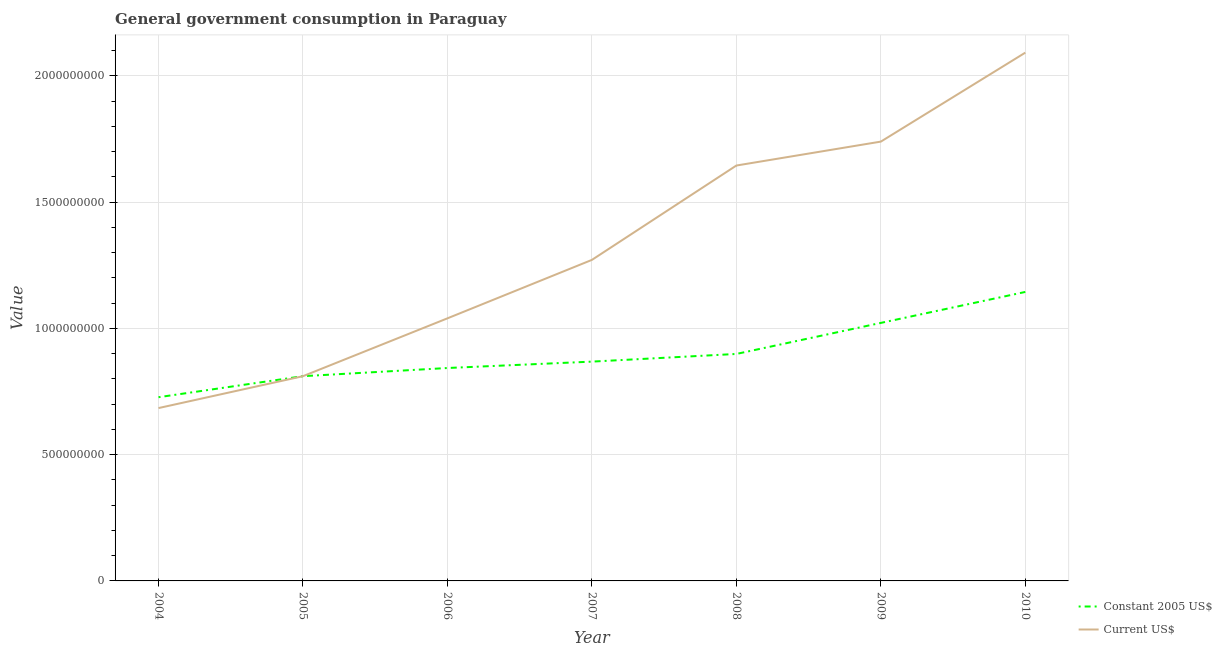How many different coloured lines are there?
Your response must be concise. 2. Does the line corresponding to value consumed in constant 2005 us$ intersect with the line corresponding to value consumed in current us$?
Offer a very short reply. Yes. Is the number of lines equal to the number of legend labels?
Offer a terse response. Yes. What is the value consumed in constant 2005 us$ in 2009?
Provide a short and direct response. 1.02e+09. Across all years, what is the maximum value consumed in current us$?
Offer a terse response. 2.09e+09. Across all years, what is the minimum value consumed in current us$?
Give a very brief answer. 6.85e+08. In which year was the value consumed in constant 2005 us$ maximum?
Your response must be concise. 2010. What is the total value consumed in constant 2005 us$ in the graph?
Provide a short and direct response. 6.32e+09. What is the difference between the value consumed in current us$ in 2009 and that in 2010?
Ensure brevity in your answer.  -3.52e+08. What is the difference between the value consumed in current us$ in 2007 and the value consumed in constant 2005 us$ in 2006?
Offer a terse response. 4.28e+08. What is the average value consumed in current us$ per year?
Your answer should be very brief. 1.33e+09. In the year 2005, what is the difference between the value consumed in current us$ and value consumed in constant 2005 us$?
Offer a terse response. 0. In how many years, is the value consumed in current us$ greater than 1300000000?
Provide a succinct answer. 3. What is the ratio of the value consumed in constant 2005 us$ in 2005 to that in 2006?
Offer a terse response. 0.96. What is the difference between the highest and the second highest value consumed in constant 2005 us$?
Provide a succinct answer. 1.23e+08. What is the difference between the highest and the lowest value consumed in constant 2005 us$?
Keep it short and to the point. 4.17e+08. In how many years, is the value consumed in current us$ greater than the average value consumed in current us$ taken over all years?
Your answer should be very brief. 3. Is the sum of the value consumed in constant 2005 us$ in 2008 and 2010 greater than the maximum value consumed in current us$ across all years?
Ensure brevity in your answer.  No. Does the value consumed in constant 2005 us$ monotonically increase over the years?
Give a very brief answer. Yes. Is the value consumed in constant 2005 us$ strictly less than the value consumed in current us$ over the years?
Make the answer very short. No. Are the values on the major ticks of Y-axis written in scientific E-notation?
Your answer should be compact. No. Does the graph contain any zero values?
Your answer should be very brief. No. Does the graph contain grids?
Keep it short and to the point. Yes. Where does the legend appear in the graph?
Your answer should be compact. Bottom right. How are the legend labels stacked?
Provide a succinct answer. Vertical. What is the title of the graph?
Your answer should be compact. General government consumption in Paraguay. What is the label or title of the X-axis?
Ensure brevity in your answer.  Year. What is the label or title of the Y-axis?
Provide a succinct answer. Value. What is the Value in Constant 2005 US$ in 2004?
Ensure brevity in your answer.  7.28e+08. What is the Value in Current US$ in 2004?
Your answer should be very brief. 6.85e+08. What is the Value in Constant 2005 US$ in 2005?
Keep it short and to the point. 8.11e+08. What is the Value in Current US$ in 2005?
Offer a terse response. 8.11e+08. What is the Value of Constant 2005 US$ in 2006?
Give a very brief answer. 8.43e+08. What is the Value in Current US$ in 2006?
Give a very brief answer. 1.04e+09. What is the Value in Constant 2005 US$ in 2007?
Provide a succinct answer. 8.69e+08. What is the Value in Current US$ in 2007?
Offer a very short reply. 1.27e+09. What is the Value in Constant 2005 US$ in 2008?
Your response must be concise. 8.99e+08. What is the Value of Current US$ in 2008?
Your response must be concise. 1.65e+09. What is the Value in Constant 2005 US$ in 2009?
Provide a short and direct response. 1.02e+09. What is the Value of Current US$ in 2009?
Ensure brevity in your answer.  1.74e+09. What is the Value of Constant 2005 US$ in 2010?
Keep it short and to the point. 1.14e+09. What is the Value of Current US$ in 2010?
Keep it short and to the point. 2.09e+09. Across all years, what is the maximum Value in Constant 2005 US$?
Your answer should be compact. 1.14e+09. Across all years, what is the maximum Value of Current US$?
Keep it short and to the point. 2.09e+09. Across all years, what is the minimum Value in Constant 2005 US$?
Make the answer very short. 7.28e+08. Across all years, what is the minimum Value in Current US$?
Offer a very short reply. 6.85e+08. What is the total Value of Constant 2005 US$ in the graph?
Provide a succinct answer. 6.32e+09. What is the total Value in Current US$ in the graph?
Ensure brevity in your answer.  9.28e+09. What is the difference between the Value of Constant 2005 US$ in 2004 and that in 2005?
Make the answer very short. -8.33e+07. What is the difference between the Value of Current US$ in 2004 and that in 2005?
Your answer should be very brief. -1.26e+08. What is the difference between the Value of Constant 2005 US$ in 2004 and that in 2006?
Your answer should be compact. -1.16e+08. What is the difference between the Value of Current US$ in 2004 and that in 2006?
Ensure brevity in your answer.  -3.55e+08. What is the difference between the Value in Constant 2005 US$ in 2004 and that in 2007?
Ensure brevity in your answer.  -1.41e+08. What is the difference between the Value of Current US$ in 2004 and that in 2007?
Offer a very short reply. -5.87e+08. What is the difference between the Value of Constant 2005 US$ in 2004 and that in 2008?
Offer a very short reply. -1.71e+08. What is the difference between the Value in Current US$ in 2004 and that in 2008?
Keep it short and to the point. -9.61e+08. What is the difference between the Value in Constant 2005 US$ in 2004 and that in 2009?
Your response must be concise. -2.94e+08. What is the difference between the Value of Current US$ in 2004 and that in 2009?
Provide a succinct answer. -1.06e+09. What is the difference between the Value of Constant 2005 US$ in 2004 and that in 2010?
Keep it short and to the point. -4.17e+08. What is the difference between the Value in Current US$ in 2004 and that in 2010?
Ensure brevity in your answer.  -1.41e+09. What is the difference between the Value in Constant 2005 US$ in 2005 and that in 2006?
Your answer should be compact. -3.24e+07. What is the difference between the Value of Current US$ in 2005 and that in 2006?
Provide a short and direct response. -2.29e+08. What is the difference between the Value in Constant 2005 US$ in 2005 and that in 2007?
Make the answer very short. -5.77e+07. What is the difference between the Value in Current US$ in 2005 and that in 2007?
Ensure brevity in your answer.  -4.61e+08. What is the difference between the Value of Constant 2005 US$ in 2005 and that in 2008?
Keep it short and to the point. -8.81e+07. What is the difference between the Value in Current US$ in 2005 and that in 2008?
Give a very brief answer. -8.34e+08. What is the difference between the Value of Constant 2005 US$ in 2005 and that in 2009?
Provide a succinct answer. -2.11e+08. What is the difference between the Value of Current US$ in 2005 and that in 2009?
Your response must be concise. -9.29e+08. What is the difference between the Value of Constant 2005 US$ in 2005 and that in 2010?
Make the answer very short. -3.34e+08. What is the difference between the Value of Current US$ in 2005 and that in 2010?
Offer a very short reply. -1.28e+09. What is the difference between the Value of Constant 2005 US$ in 2006 and that in 2007?
Your answer should be compact. -2.53e+07. What is the difference between the Value of Current US$ in 2006 and that in 2007?
Your answer should be very brief. -2.31e+08. What is the difference between the Value of Constant 2005 US$ in 2006 and that in 2008?
Your answer should be very brief. -5.57e+07. What is the difference between the Value in Current US$ in 2006 and that in 2008?
Offer a very short reply. -6.05e+08. What is the difference between the Value of Constant 2005 US$ in 2006 and that in 2009?
Your answer should be very brief. -1.79e+08. What is the difference between the Value in Current US$ in 2006 and that in 2009?
Offer a very short reply. -7.00e+08. What is the difference between the Value of Constant 2005 US$ in 2006 and that in 2010?
Ensure brevity in your answer.  -3.01e+08. What is the difference between the Value of Current US$ in 2006 and that in 2010?
Provide a succinct answer. -1.05e+09. What is the difference between the Value of Constant 2005 US$ in 2007 and that in 2008?
Provide a succinct answer. -3.04e+07. What is the difference between the Value of Current US$ in 2007 and that in 2008?
Your response must be concise. -3.74e+08. What is the difference between the Value of Constant 2005 US$ in 2007 and that in 2009?
Your response must be concise. -1.53e+08. What is the difference between the Value of Current US$ in 2007 and that in 2009?
Provide a succinct answer. -4.68e+08. What is the difference between the Value of Constant 2005 US$ in 2007 and that in 2010?
Make the answer very short. -2.76e+08. What is the difference between the Value in Current US$ in 2007 and that in 2010?
Your answer should be compact. -8.21e+08. What is the difference between the Value in Constant 2005 US$ in 2008 and that in 2009?
Your answer should be compact. -1.23e+08. What is the difference between the Value in Current US$ in 2008 and that in 2009?
Your answer should be very brief. -9.47e+07. What is the difference between the Value in Constant 2005 US$ in 2008 and that in 2010?
Offer a terse response. -2.46e+08. What is the difference between the Value of Current US$ in 2008 and that in 2010?
Make the answer very short. -4.47e+08. What is the difference between the Value in Constant 2005 US$ in 2009 and that in 2010?
Your response must be concise. -1.23e+08. What is the difference between the Value in Current US$ in 2009 and that in 2010?
Ensure brevity in your answer.  -3.52e+08. What is the difference between the Value of Constant 2005 US$ in 2004 and the Value of Current US$ in 2005?
Your answer should be very brief. -8.33e+07. What is the difference between the Value of Constant 2005 US$ in 2004 and the Value of Current US$ in 2006?
Provide a succinct answer. -3.12e+08. What is the difference between the Value of Constant 2005 US$ in 2004 and the Value of Current US$ in 2007?
Your answer should be very brief. -5.44e+08. What is the difference between the Value in Constant 2005 US$ in 2004 and the Value in Current US$ in 2008?
Your answer should be very brief. -9.18e+08. What is the difference between the Value in Constant 2005 US$ in 2004 and the Value in Current US$ in 2009?
Ensure brevity in your answer.  -1.01e+09. What is the difference between the Value of Constant 2005 US$ in 2004 and the Value of Current US$ in 2010?
Your answer should be very brief. -1.36e+09. What is the difference between the Value of Constant 2005 US$ in 2005 and the Value of Current US$ in 2006?
Your answer should be very brief. -2.29e+08. What is the difference between the Value of Constant 2005 US$ in 2005 and the Value of Current US$ in 2007?
Offer a terse response. -4.61e+08. What is the difference between the Value of Constant 2005 US$ in 2005 and the Value of Current US$ in 2008?
Make the answer very short. -8.34e+08. What is the difference between the Value of Constant 2005 US$ in 2005 and the Value of Current US$ in 2009?
Offer a terse response. -9.29e+08. What is the difference between the Value in Constant 2005 US$ in 2005 and the Value in Current US$ in 2010?
Provide a short and direct response. -1.28e+09. What is the difference between the Value of Constant 2005 US$ in 2006 and the Value of Current US$ in 2007?
Provide a succinct answer. -4.28e+08. What is the difference between the Value of Constant 2005 US$ in 2006 and the Value of Current US$ in 2008?
Ensure brevity in your answer.  -8.02e+08. What is the difference between the Value in Constant 2005 US$ in 2006 and the Value in Current US$ in 2009?
Ensure brevity in your answer.  -8.97e+08. What is the difference between the Value in Constant 2005 US$ in 2006 and the Value in Current US$ in 2010?
Your answer should be compact. -1.25e+09. What is the difference between the Value in Constant 2005 US$ in 2007 and the Value in Current US$ in 2008?
Give a very brief answer. -7.77e+08. What is the difference between the Value in Constant 2005 US$ in 2007 and the Value in Current US$ in 2009?
Provide a succinct answer. -8.71e+08. What is the difference between the Value of Constant 2005 US$ in 2007 and the Value of Current US$ in 2010?
Provide a succinct answer. -1.22e+09. What is the difference between the Value of Constant 2005 US$ in 2008 and the Value of Current US$ in 2009?
Your response must be concise. -8.41e+08. What is the difference between the Value of Constant 2005 US$ in 2008 and the Value of Current US$ in 2010?
Offer a terse response. -1.19e+09. What is the difference between the Value of Constant 2005 US$ in 2009 and the Value of Current US$ in 2010?
Ensure brevity in your answer.  -1.07e+09. What is the average Value in Constant 2005 US$ per year?
Offer a very short reply. 9.02e+08. What is the average Value of Current US$ per year?
Ensure brevity in your answer.  1.33e+09. In the year 2004, what is the difference between the Value of Constant 2005 US$ and Value of Current US$?
Your response must be concise. 4.30e+07. In the year 2005, what is the difference between the Value in Constant 2005 US$ and Value in Current US$?
Ensure brevity in your answer.  0. In the year 2006, what is the difference between the Value in Constant 2005 US$ and Value in Current US$?
Provide a short and direct response. -1.97e+08. In the year 2007, what is the difference between the Value in Constant 2005 US$ and Value in Current US$?
Ensure brevity in your answer.  -4.03e+08. In the year 2008, what is the difference between the Value of Constant 2005 US$ and Value of Current US$?
Give a very brief answer. -7.46e+08. In the year 2009, what is the difference between the Value of Constant 2005 US$ and Value of Current US$?
Your response must be concise. -7.18e+08. In the year 2010, what is the difference between the Value in Constant 2005 US$ and Value in Current US$?
Offer a very short reply. -9.48e+08. What is the ratio of the Value in Constant 2005 US$ in 2004 to that in 2005?
Your answer should be very brief. 0.9. What is the ratio of the Value in Current US$ in 2004 to that in 2005?
Give a very brief answer. 0.84. What is the ratio of the Value of Constant 2005 US$ in 2004 to that in 2006?
Your response must be concise. 0.86. What is the ratio of the Value in Current US$ in 2004 to that in 2006?
Your response must be concise. 0.66. What is the ratio of the Value in Constant 2005 US$ in 2004 to that in 2007?
Ensure brevity in your answer.  0.84. What is the ratio of the Value in Current US$ in 2004 to that in 2007?
Provide a succinct answer. 0.54. What is the ratio of the Value of Constant 2005 US$ in 2004 to that in 2008?
Your response must be concise. 0.81. What is the ratio of the Value of Current US$ in 2004 to that in 2008?
Your answer should be very brief. 0.42. What is the ratio of the Value in Constant 2005 US$ in 2004 to that in 2009?
Your response must be concise. 0.71. What is the ratio of the Value of Current US$ in 2004 to that in 2009?
Keep it short and to the point. 0.39. What is the ratio of the Value of Constant 2005 US$ in 2004 to that in 2010?
Provide a succinct answer. 0.64. What is the ratio of the Value in Current US$ in 2004 to that in 2010?
Offer a very short reply. 0.33. What is the ratio of the Value of Constant 2005 US$ in 2005 to that in 2006?
Provide a succinct answer. 0.96. What is the ratio of the Value of Current US$ in 2005 to that in 2006?
Keep it short and to the point. 0.78. What is the ratio of the Value in Constant 2005 US$ in 2005 to that in 2007?
Your answer should be compact. 0.93. What is the ratio of the Value of Current US$ in 2005 to that in 2007?
Keep it short and to the point. 0.64. What is the ratio of the Value of Constant 2005 US$ in 2005 to that in 2008?
Provide a succinct answer. 0.9. What is the ratio of the Value in Current US$ in 2005 to that in 2008?
Your answer should be compact. 0.49. What is the ratio of the Value of Constant 2005 US$ in 2005 to that in 2009?
Offer a terse response. 0.79. What is the ratio of the Value in Current US$ in 2005 to that in 2009?
Make the answer very short. 0.47. What is the ratio of the Value of Constant 2005 US$ in 2005 to that in 2010?
Offer a very short reply. 0.71. What is the ratio of the Value in Current US$ in 2005 to that in 2010?
Provide a succinct answer. 0.39. What is the ratio of the Value in Constant 2005 US$ in 2006 to that in 2007?
Offer a very short reply. 0.97. What is the ratio of the Value of Current US$ in 2006 to that in 2007?
Offer a terse response. 0.82. What is the ratio of the Value in Constant 2005 US$ in 2006 to that in 2008?
Your answer should be very brief. 0.94. What is the ratio of the Value in Current US$ in 2006 to that in 2008?
Your answer should be compact. 0.63. What is the ratio of the Value in Constant 2005 US$ in 2006 to that in 2009?
Your answer should be compact. 0.83. What is the ratio of the Value of Current US$ in 2006 to that in 2009?
Make the answer very short. 0.6. What is the ratio of the Value of Constant 2005 US$ in 2006 to that in 2010?
Your answer should be very brief. 0.74. What is the ratio of the Value in Current US$ in 2006 to that in 2010?
Offer a terse response. 0.5. What is the ratio of the Value of Constant 2005 US$ in 2007 to that in 2008?
Keep it short and to the point. 0.97. What is the ratio of the Value in Current US$ in 2007 to that in 2008?
Offer a very short reply. 0.77. What is the ratio of the Value in Constant 2005 US$ in 2007 to that in 2009?
Ensure brevity in your answer.  0.85. What is the ratio of the Value of Current US$ in 2007 to that in 2009?
Provide a short and direct response. 0.73. What is the ratio of the Value of Constant 2005 US$ in 2007 to that in 2010?
Keep it short and to the point. 0.76. What is the ratio of the Value in Current US$ in 2007 to that in 2010?
Offer a very short reply. 0.61. What is the ratio of the Value of Constant 2005 US$ in 2008 to that in 2009?
Your answer should be compact. 0.88. What is the ratio of the Value in Current US$ in 2008 to that in 2009?
Provide a short and direct response. 0.95. What is the ratio of the Value in Constant 2005 US$ in 2008 to that in 2010?
Offer a terse response. 0.79. What is the ratio of the Value in Current US$ in 2008 to that in 2010?
Make the answer very short. 0.79. What is the ratio of the Value of Constant 2005 US$ in 2009 to that in 2010?
Offer a very short reply. 0.89. What is the ratio of the Value in Current US$ in 2009 to that in 2010?
Provide a succinct answer. 0.83. What is the difference between the highest and the second highest Value of Constant 2005 US$?
Provide a short and direct response. 1.23e+08. What is the difference between the highest and the second highest Value in Current US$?
Offer a very short reply. 3.52e+08. What is the difference between the highest and the lowest Value in Constant 2005 US$?
Offer a very short reply. 4.17e+08. What is the difference between the highest and the lowest Value of Current US$?
Offer a very short reply. 1.41e+09. 